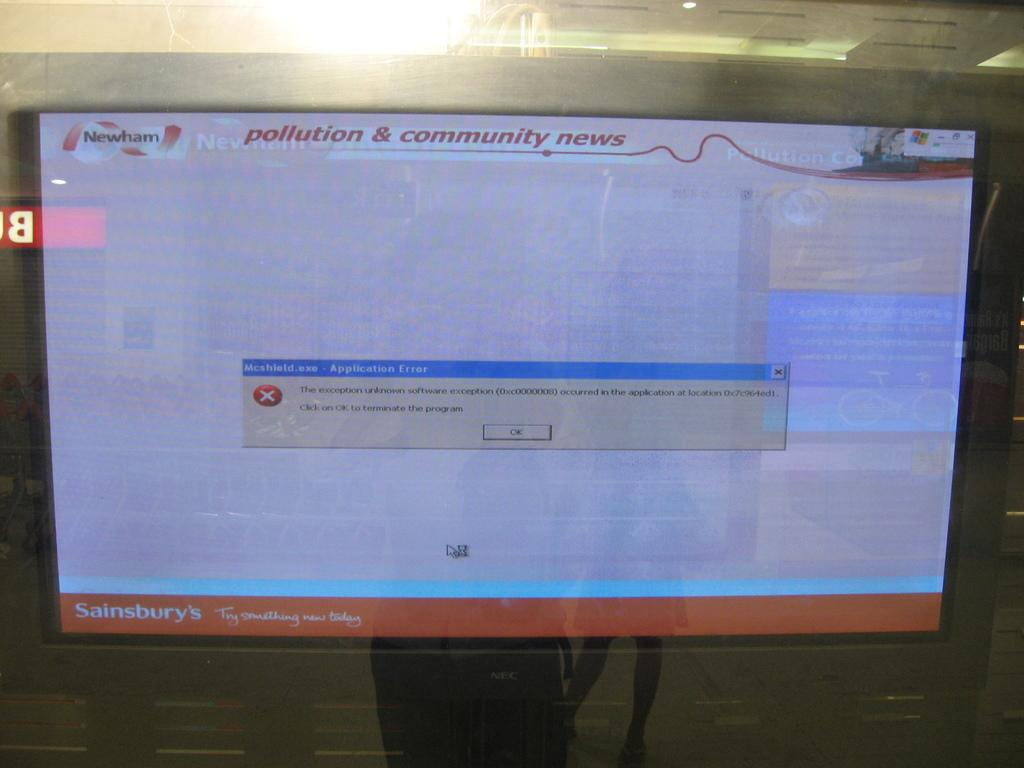<image>
Write a terse but informative summary of the picture. a computer screen with an error message on it, with the title 'pollution & community news' 